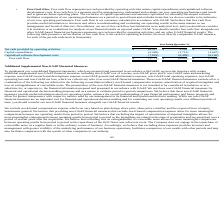According to Everbridge's financial document, What does Free Cash Flow represent? net cash provided by operating activities minus capital expenditures and capitalized software development costs.. The document states: "• Free Cash Flow . Free cash flow represents net cash provided by operating activities minus capital expenditures and capitalized software development..." Also, What is Free Cash Flow used as? by management to understand and evaluate our core operating performance and trends and to generate future operating plans.. The document states: "evelopment costs. Free cash flow is a measure used by management to understand and evaluate our core operating performance and trends and to generate ..." Also, What was the Net cash provided by operating activities in 2019, 2018 and 2017 respectively? The document contains multiple relevant values: 10,317, 3,295, 4,863. From the document: "cash provided by operating activities $ 10,317 $ 3,295 $ 4,863 ovided by operating activities $ 10,317 $ 3,295 $ 4,863 Net cash provided by operating ..." Also, can you calculate: What was the average Net cash provided by operating activities from 2017-2019? To answer this question, I need to perform calculations using the financial data. The calculation is: (10,317 + 3,295 + 4,863) / 3, which equals 6158.33 (in thousands). This is based on the information: "cash provided by operating activities $ 10,317 $ 3,295 $ 4,863 ovided by operating activities $ 10,317 $ 3,295 $ 4,863 Net cash provided by operating activities $ 10,317 $ 3,295 $ 4,863..." The key data points involved are: 10,317, 3,295, 4,863. Also, can you calculate: What was the change in the Capital expenditures from 2018 to 2019? Based on the calculation: -5,269 - (- 1,721), the result is -3548 (in thousands). This is based on the information: "Capital expenditures (5,269) (1,721) (1,667) Capital expenditures (5,269) (1,721) (1,667)..." The key data points involved are: 1,721, 5,269. Additionally, In which year was Net cash provided by operating activities less than 5,000 thousands? The document shows two values: 2018 and 2017. Locate and analyze net cash provided by operating activities in row 3. From the document: "2019 2018 2017 2019 2018 2017..." 